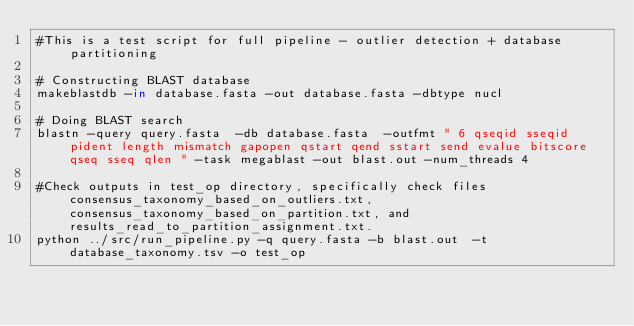Convert code to text. <code><loc_0><loc_0><loc_500><loc_500><_Bash_>#This is a test script for full pipeline - outlier detection + database partitioning

# Constructing BLAST database
makeblastdb -in database.fasta -out database.fasta -dbtype nucl

# Doing BLAST search
blastn -query query.fasta  -db database.fasta  -outfmt " 6 qseqid sseqid pident length mismatch gapopen qstart qend sstart send evalue bitscore qseq sseq qlen " -task megablast -out blast.out -num_threads 4

#Check outputs in test_op directory, specifically check files consensus_taxonomy_based_on_outliers.txt, consensus_taxonomy_based_on_partition.txt, and results_read_to_partition_assignment.txt.
python ../src/run_pipeline.py -q query.fasta -b blast.out  -t database_taxonomy.tsv -o test_op</code> 